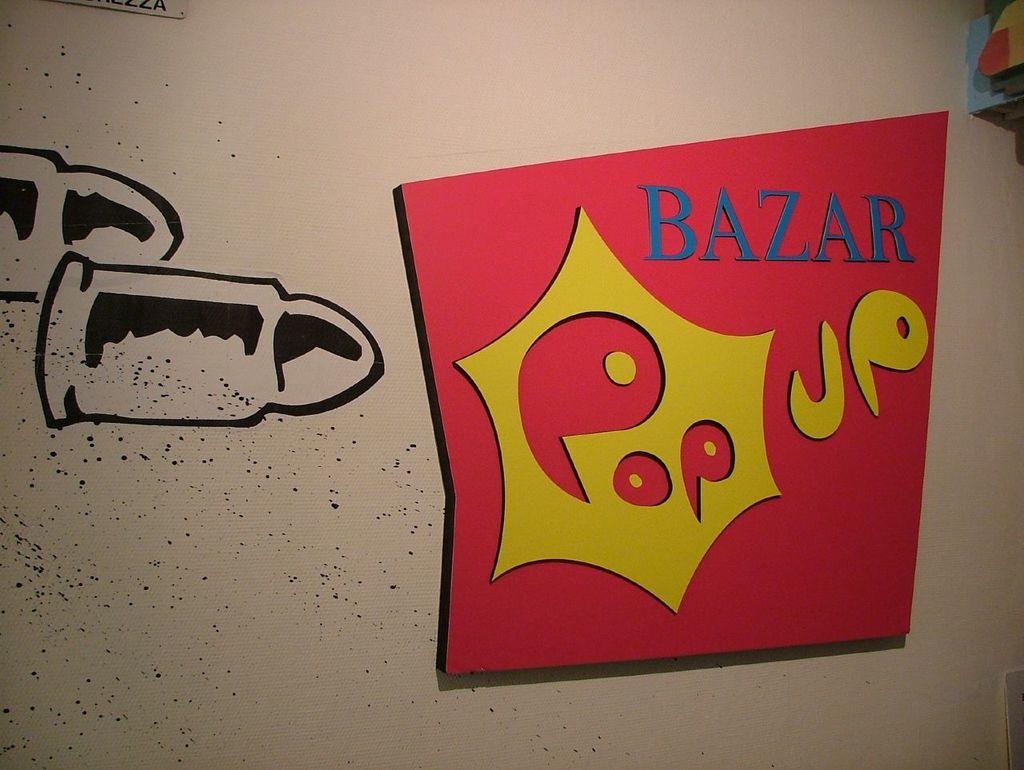What type of pop up do the letters in blue describe?
Make the answer very short. Bazar. What kind of baazer is shown in the red poster?
Give a very brief answer. Pop up. 